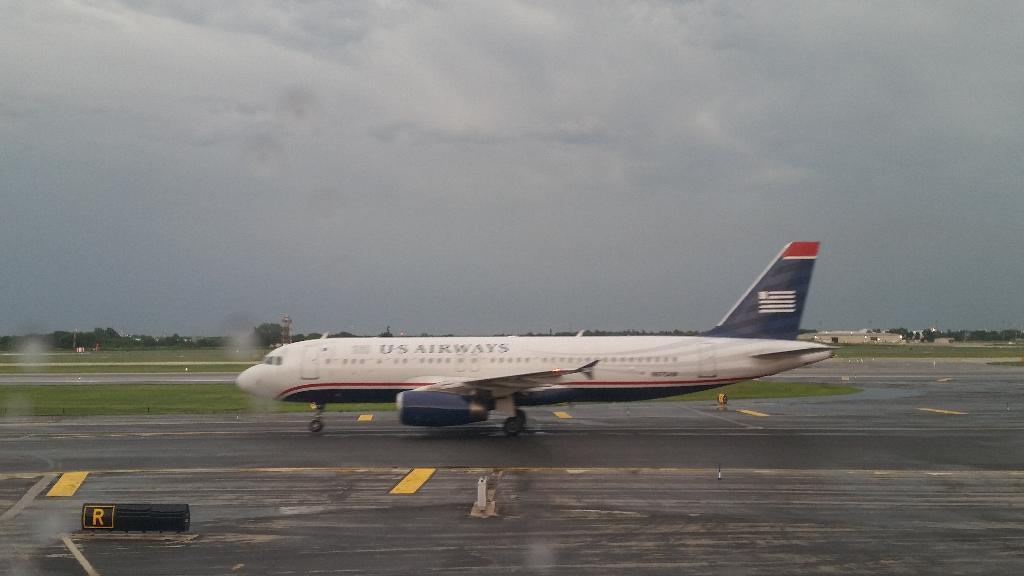What is located on the runway in the image? There is a flight on the runway in the image. What type of surface is behind the flight? There is a grass surface behind the flight. What can be seen in the background of the image? Trees and the sky are visible in the background of the image. What is the condition of the sky in the image? Clouds are present in the sky. What type of cable can be seen connecting the flight to the trees in the image? There is no cable connecting the flight to the trees in the image. Can you tell me how many kitties are playing on the grass surface in the image? There are no kitties present in the image; it features a flight on the runway and a grass surface behind it. 